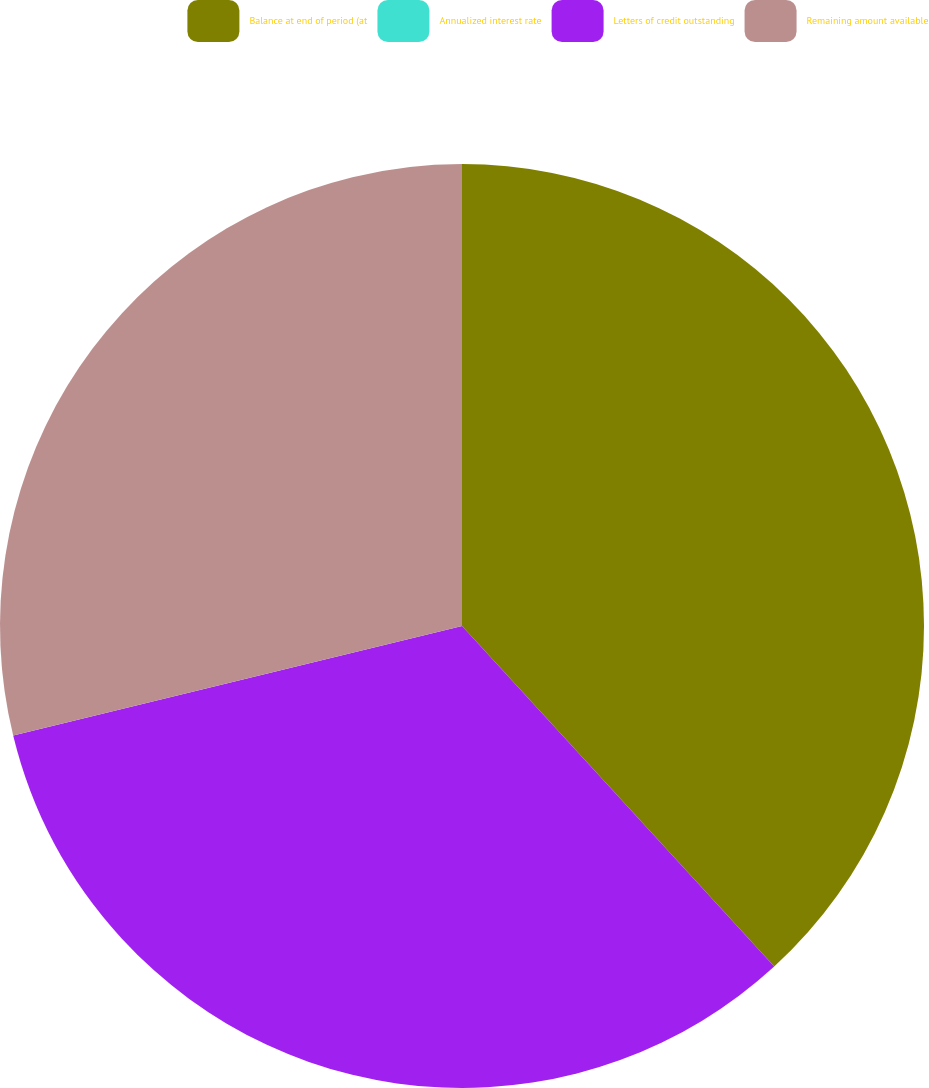Convert chart. <chart><loc_0><loc_0><loc_500><loc_500><pie_chart><fcel>Balance at end of period (at<fcel>Annualized interest rate<fcel>Letters of credit outstanding<fcel>Remaining amount available<nl><fcel>38.19%<fcel>0.0%<fcel>33.0%<fcel>28.81%<nl></chart> 